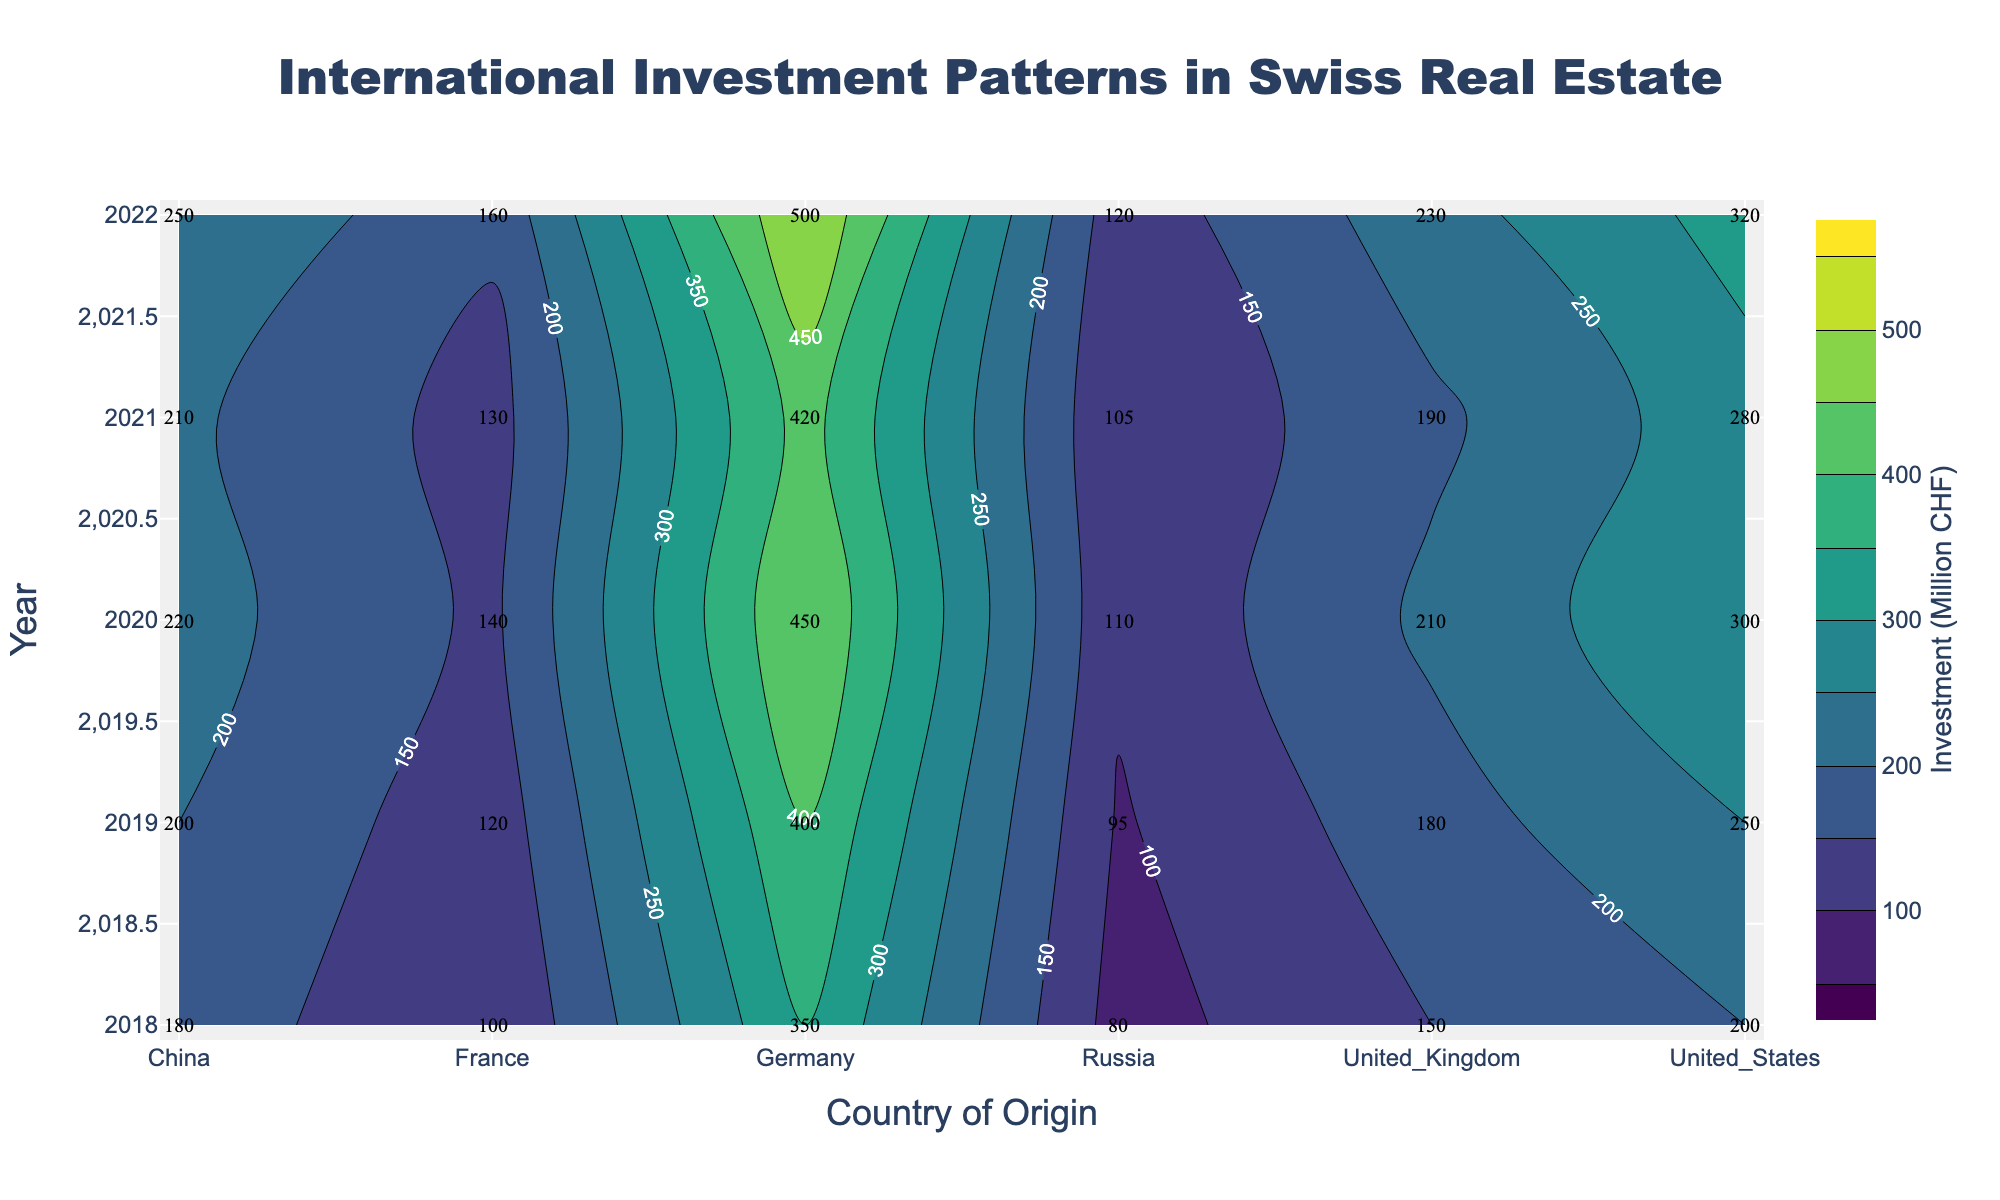what is the title of the plot? The title of the plot is generally located at the top center of the figure. In this plot, it is labeled prominently with a larger font size than other texts.
Answer: International Investment Patterns in Swiss Real Estate what are the units of investment in Swiss real estate on the plot? Units of investment are usually indicated in the color bar title on the right of the contour plot. In this case, it denotes "Investment (Million CHF)".
Answer: Million CHF which country had the highest investment in 2022? Find the contour label corresponding to 2022 across different countries and identify the highest value. For 2022, Germany shows the highest investment at 500 Million CHF.
Answer: Germany how did the investment from the United States change from 2018 to 2022? Locate the contour labels of the United States from 2018 to 2022 sequentially and observe their values: 200, 250, 300, 280, 320. The investment increased overall.
Answer: Increased compare the investment amount from China and Russia in 2021. Which country invested more? Refer to the contour labels for China and Russia for the year 2021. China invested 210 Million CHF and Russia invested 105 Million CHF. Comparing these two values, China invested more.
Answer: China what is the average annual investment from France between 2018 and 2022? Sum the investments of France from 2018 to 2022 (100, 120, 140, 130, 160) and divide by the number of years (5). (100 + 120 + 140 + 130 + 160) / 5 = 650 / 5 = 130 Million CHF.
Answer: 130 Million CHF what is the range of investments for the United Kingdom from 2018 to 2022? Identify the investment values of the United Kingdom for 2018 to 2022 (150, 180, 210, 190, 230). The range is obtained by subtracting the minimum value from the maximum value: 230 - 150 = 80 Million CHF.
Answer: 80 Million CHF did any country have a year with investment below 100 Million CHF? If so, which one(s)? Review the contour labels for all years across all countries looking for values below 100 Million CHF. Russia is the only country with investments below 100 Million CHF in 2018 (80 Million CHF) and 2019 (95 Million CHF).
Answer: Russia describe the trend for German investments from 2018 to 2022. Locate the contour labels for Germany from 2018 to 2022 (350, 400, 450, 420, 500) and observe the trend. The investments generally increase over the years with a slight drop in 2021 but the trend is upward.
Answer: Increasing with a slight drop in 2021 what was the total investment in 2020 from all listed countries? Sum the investments from all countries for the year 2020 (Germany: 450, United States: 300, United Kingdom: 210, France: 140, China: 220, Russia: 110). The total is 450 + 300 + 210 + 140 + 220 + 110 = 1430 Million CHF.
Answer: 1430 Million CHF 